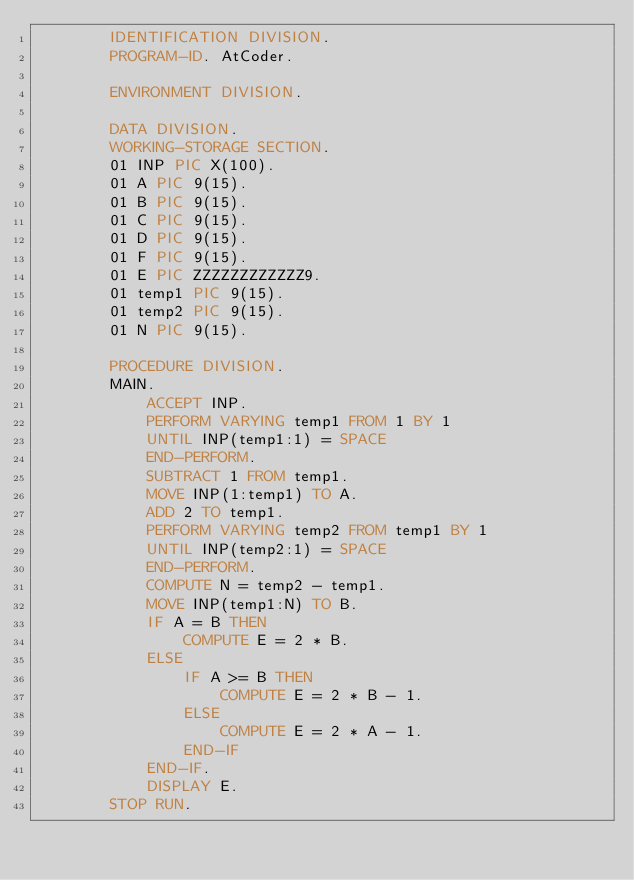<code> <loc_0><loc_0><loc_500><loc_500><_COBOL_>		IDENTIFICATION DIVISION.
        PROGRAM-ID. AtCoder.
      
        ENVIRONMENT DIVISION.
      
        DATA DIVISION.
        WORKING-STORAGE SECTION.
        01 INP PIC X(100).
        01 A PIC 9(15).
        01 B PIC 9(15).
        01 C PIC 9(15).
      	01 D PIC 9(15).
      	01 F PIC 9(15).
      	01 E PIC ZZZZZZZZZZZZ9.
	    01 temp1 PIC 9(15).
        01 temp2 PIC 9(15).
        01 N PIC 9(15).
      
        PROCEDURE DIVISION.
      	MAIN.
			ACCEPT INP.
        	PERFORM VARYING temp1 FROM 1 BY 1
            UNTIL INP(temp1:1) = SPACE
        	END-PERFORM.
        	SUBTRACT 1 FROM temp1.
        	MOVE INP(1:temp1) TO A.
        	ADD 2 TO temp1.
        	PERFORM VARYING temp2 FROM temp1 BY 1
            UNTIL INP(temp2:1) = SPACE
        	END-PERFORM.
        	COMPUTE N = temp2 - temp1.
        	MOVE INP(temp1:N) TO B.
      		IF A = B THEN
      			COMPUTE E = 2 * B.
      		ELSE
      			IF A >= B THEN
      				COMPUTE E = 2 * B - 1.
      			ELSE
      				COMPUTE E = 2 * A - 1.
      			END-IF
      		END-IF.
      		DISPLAY E.
		STOP RUN.</code> 